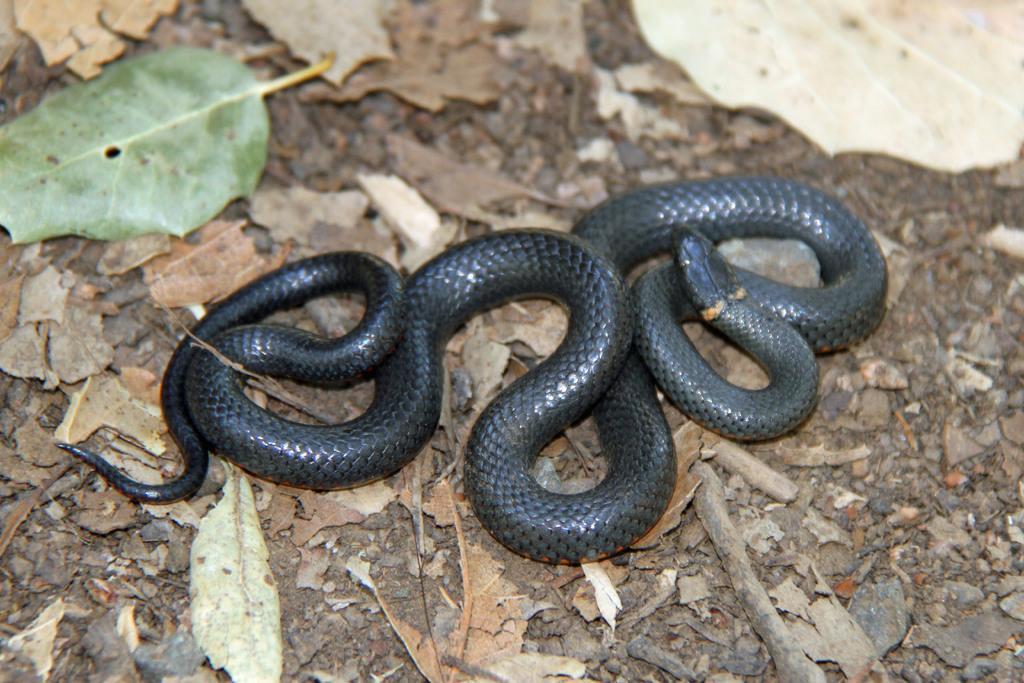How would you summarize this image in a sentence or two? In this image we can see a black color snake on the ground. Here we can see the dry leaves. 